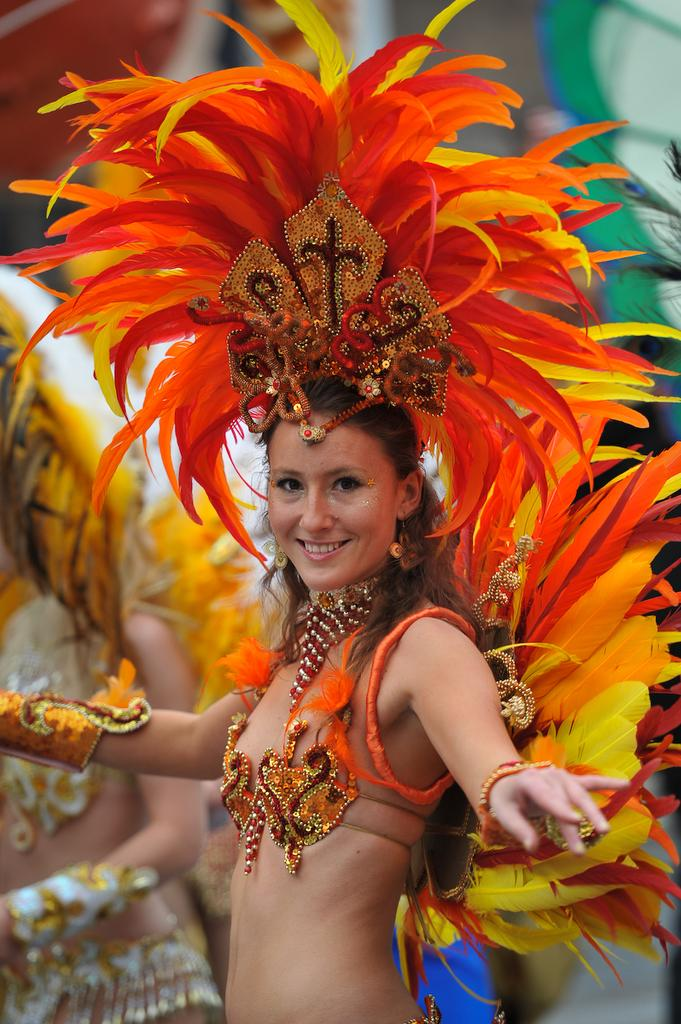Who is the main subject in the image? There is a woman in the image. What is the woman doing in the image? The woman is standing in the image. What is the woman's facial expression in the image? The woman is smiling in the image. What can be seen on the woman's head in the image? There is an orange color object on the woman's head. What type of action is the woman taking with the oranges in the image? There are no oranges present in the image, and the woman is not taking any action with them. What type of authority does the woman have in the image? There is no indication of the woman's authority in the image. 